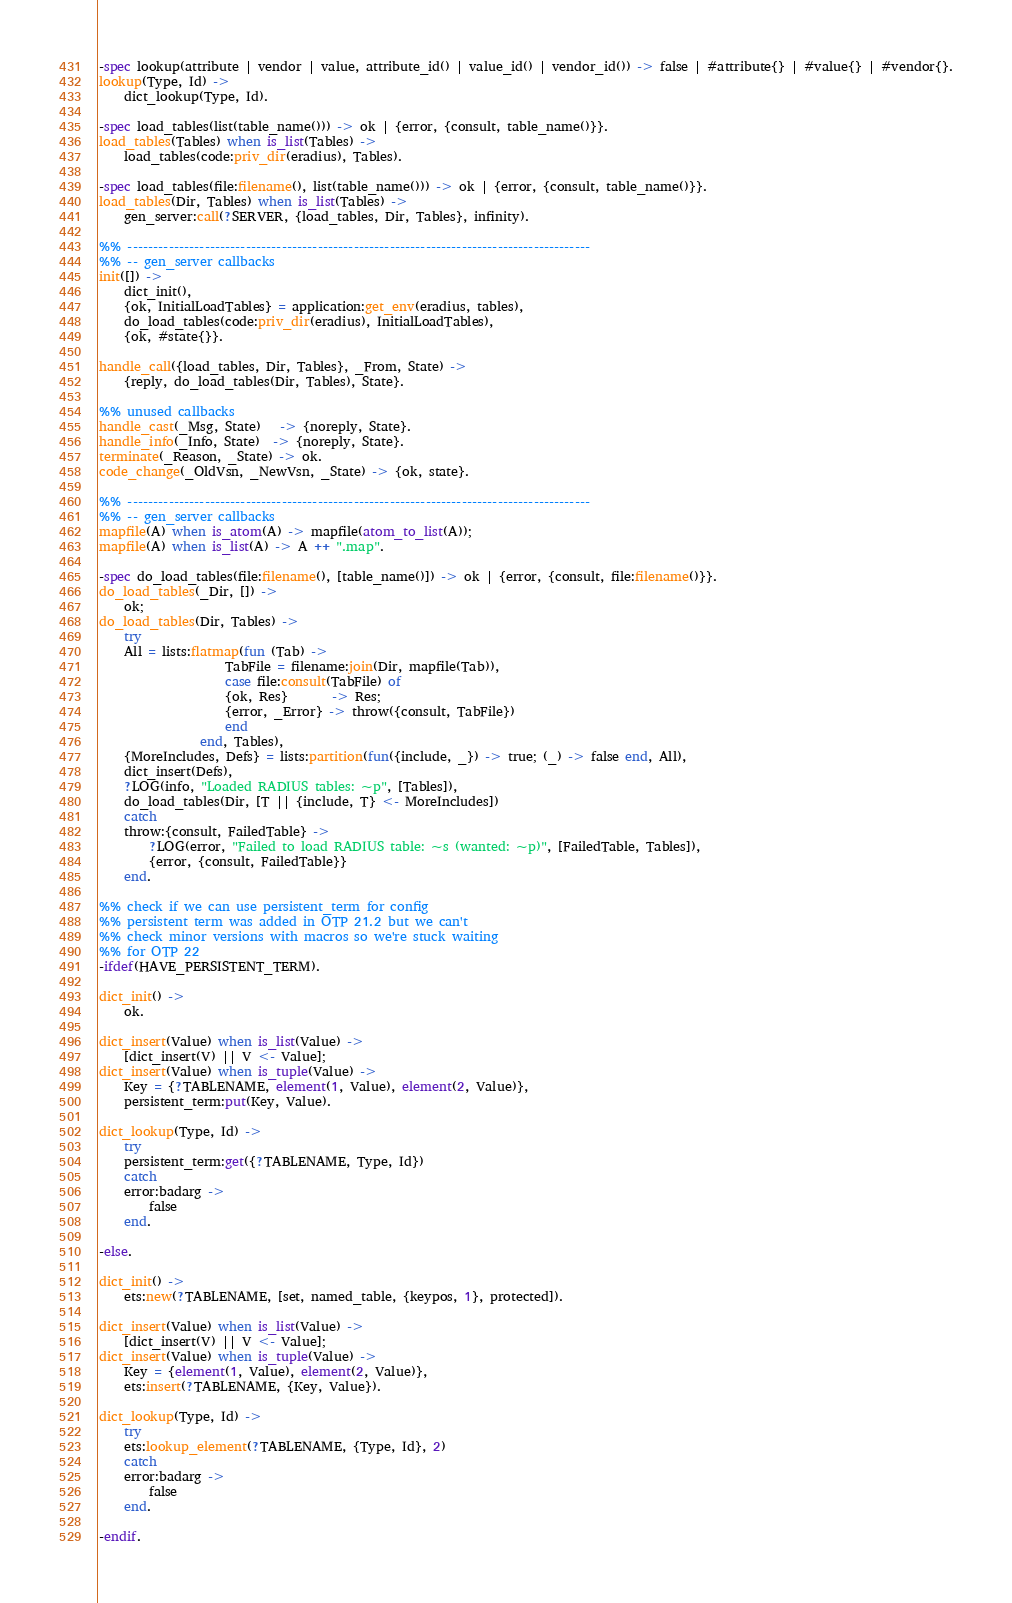<code> <loc_0><loc_0><loc_500><loc_500><_Erlang_>-spec lookup(attribute | vendor | value, attribute_id() | value_id() | vendor_id()) -> false | #attribute{} | #value{} | #vendor{}.
lookup(Type, Id) ->
    dict_lookup(Type, Id).

-spec load_tables(list(table_name())) -> ok | {error, {consult, table_name()}}.
load_tables(Tables) when is_list(Tables) ->
    load_tables(code:priv_dir(eradius), Tables).

-spec load_tables(file:filename(), list(table_name())) -> ok | {error, {consult, table_name()}}.
load_tables(Dir, Tables) when is_list(Tables) ->
    gen_server:call(?SERVER, {load_tables, Dir, Tables}, infinity).

%% ------------------------------------------------------------------------------------------
%% -- gen_server callbacks
init([]) ->
    dict_init(),
    {ok, InitialLoadTables} = application:get_env(eradius, tables),
    do_load_tables(code:priv_dir(eradius), InitialLoadTables),
    {ok, #state{}}.

handle_call({load_tables, Dir, Tables}, _From, State) ->
    {reply, do_load_tables(Dir, Tables), State}.

%% unused callbacks
handle_cast(_Msg, State)   -> {noreply, State}.
handle_info(_Info, State)  -> {noreply, State}.
terminate(_Reason, _State) -> ok.
code_change(_OldVsn, _NewVsn, _State) -> {ok, state}.

%% ------------------------------------------------------------------------------------------
%% -- gen_server callbacks
mapfile(A) when is_atom(A) -> mapfile(atom_to_list(A));
mapfile(A) when is_list(A) -> A ++ ".map".

-spec do_load_tables(file:filename(), [table_name()]) -> ok | {error, {consult, file:filename()}}.
do_load_tables(_Dir, []) ->
    ok;
do_load_tables(Dir, Tables) ->
    try
	All = lists:flatmap(fun (Tab) ->
				    TabFile = filename:join(Dir, mapfile(Tab)),
				    case file:consult(TabFile) of
					{ok, Res}       -> Res;
					{error, _Error} -> throw({consult, TabFile})
				    end
			    end, Tables),
	{MoreIncludes, Defs} = lists:partition(fun({include, _}) -> true; (_) -> false end, All),
	dict_insert(Defs),
	?LOG(info, "Loaded RADIUS tables: ~p", [Tables]),
	do_load_tables(Dir, [T || {include, T} <- MoreIncludes])
    catch
	throw:{consult, FailedTable} ->
	    ?LOG(error, "Failed to load RADIUS table: ~s (wanted: ~p)", [FailedTable, Tables]),
	    {error, {consult, FailedTable}}
    end.

%% check if we can use persistent_term for config
%% persistent term was added in OTP 21.2 but we can't
%% check minor versions with macros so we're stuck waiting
%% for OTP 22
-ifdef(HAVE_PERSISTENT_TERM).

dict_init() ->
    ok.

dict_insert(Value) when is_list(Value) ->
    [dict_insert(V) || V <- Value];
dict_insert(Value) when is_tuple(Value) ->
    Key = {?TABLENAME, element(1, Value), element(2, Value)},
    persistent_term:put(Key, Value).

dict_lookup(Type, Id) ->
    try
	persistent_term:get({?TABLENAME, Type, Id})
    catch
	error:badarg ->
	    false
    end.

-else.

dict_init() ->
    ets:new(?TABLENAME, [set, named_table, {keypos, 1}, protected]).

dict_insert(Value) when is_list(Value) ->
    [dict_insert(V) || V <- Value];
dict_insert(Value) when is_tuple(Value) ->
    Key = {element(1, Value), element(2, Value)},
    ets:insert(?TABLENAME, {Key, Value}).

dict_lookup(Type, Id) ->
    try
	ets:lookup_element(?TABLENAME, {Type, Id}, 2)
    catch
	error:badarg ->
	    false
    end.

-endif.
</code> 